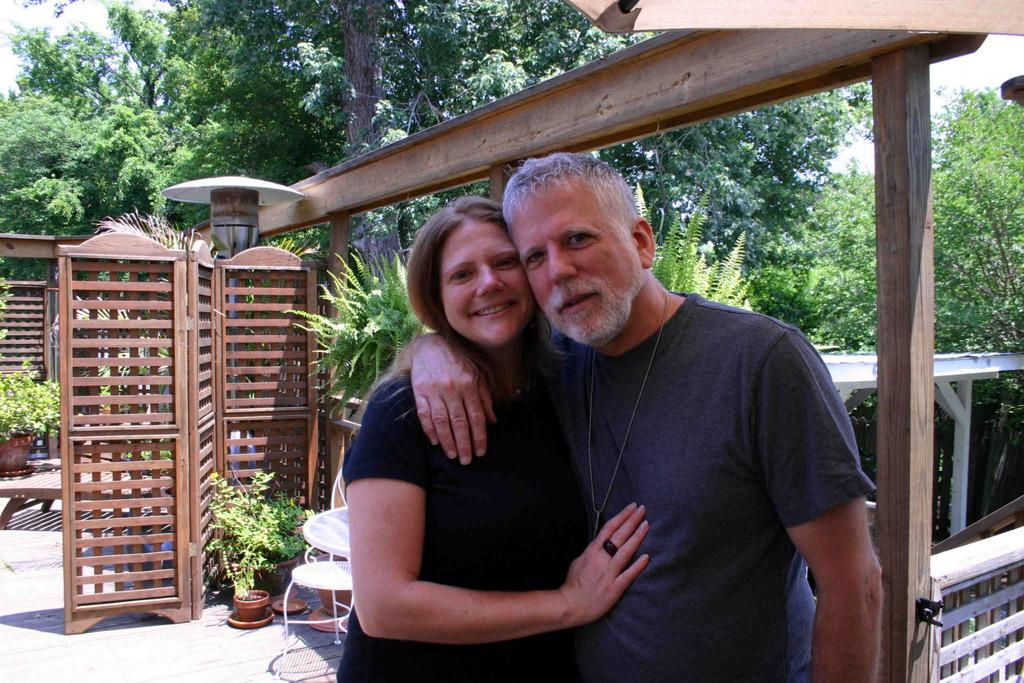Who can be seen in the foreground of the image? There is a man and a woman in the foreground of the image. What type of furniture is present in the image? There are chairs in the image. What type of vegetation can be seen in the image? There are plants and trees in the image. What type of lighting is present in the image? There is a lamp in the image. What material do the walls appear to be made of? The walls appear to be made of wood. What can be seen in the background of the image? The sky is visible in the background of the image. What type of horse can be seen in the image? There is no horse present in the image. What type of waste can be seen in the image? There is no waste present in the image. 